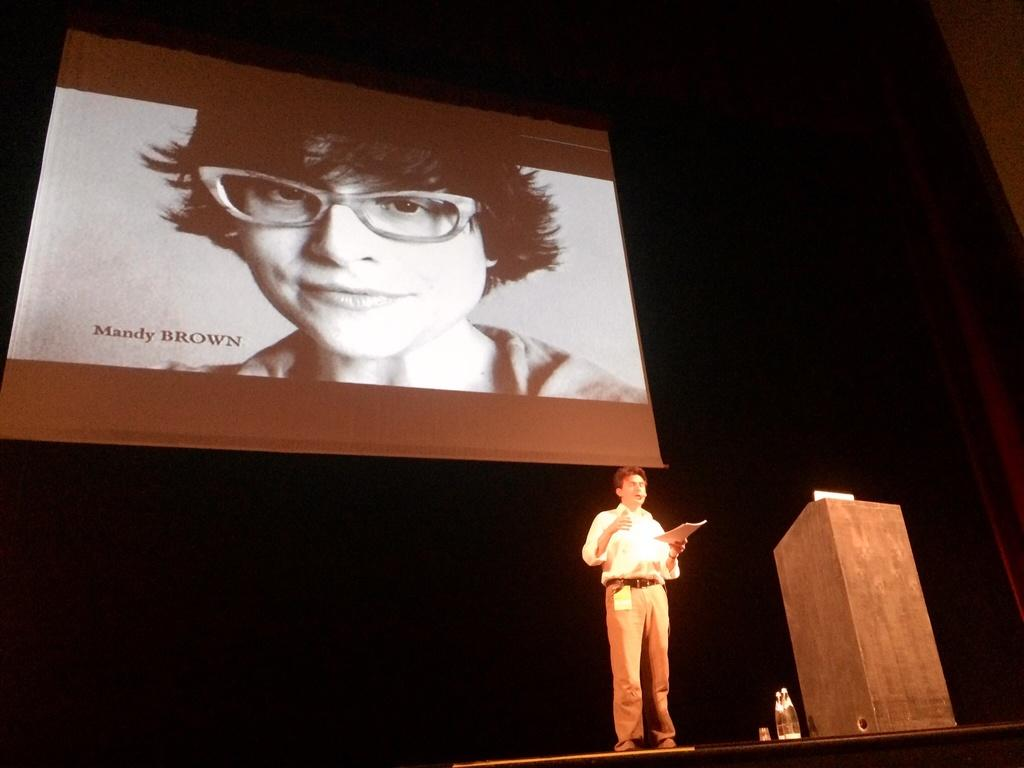What is the main feature of the image? There is a stage in the image. What can be found on the stage? There is a podium, water bottles, and a person holding a paper on the stage. What is present in the background of the image? There is a screen in the background of the image. What can be seen on the screen? There is a lady visible on the screen. What type of music can be heard coming from the church in the image? There is no church or music present in the image; it features a stage with a podium, water bottles, a person holding a paper, and a screen with a lady visible. 